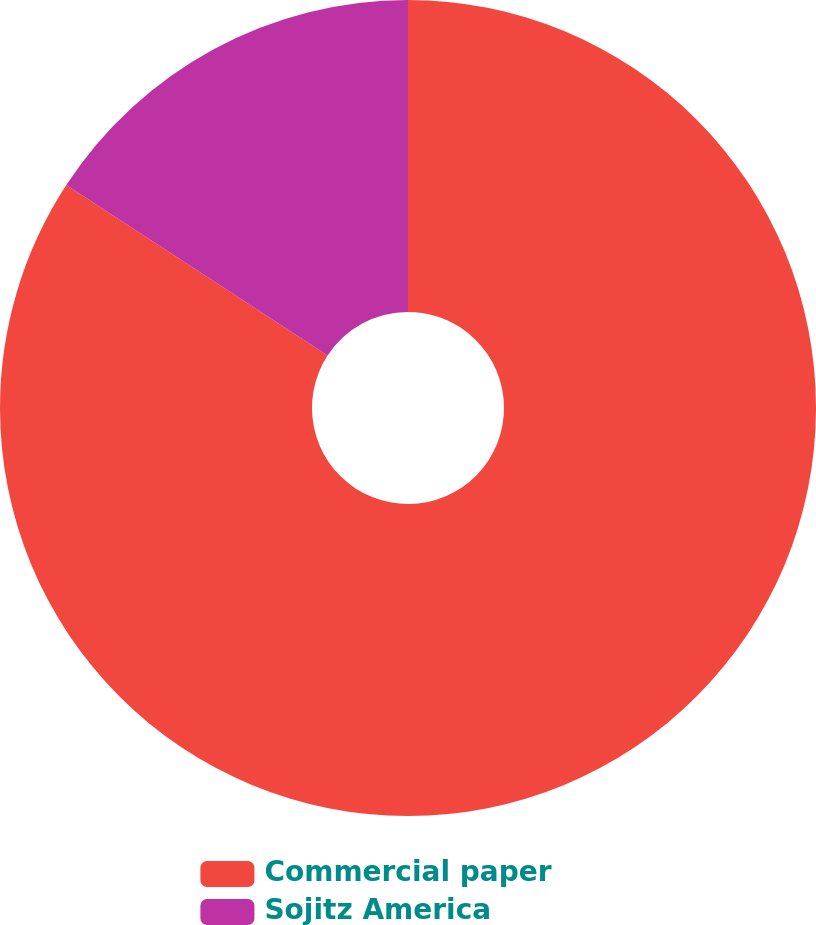Convert chart to OTSL. <chart><loc_0><loc_0><loc_500><loc_500><pie_chart><fcel>Commercial paper<fcel>Sojitz America<nl><fcel>84.2%<fcel>15.8%<nl></chart> 